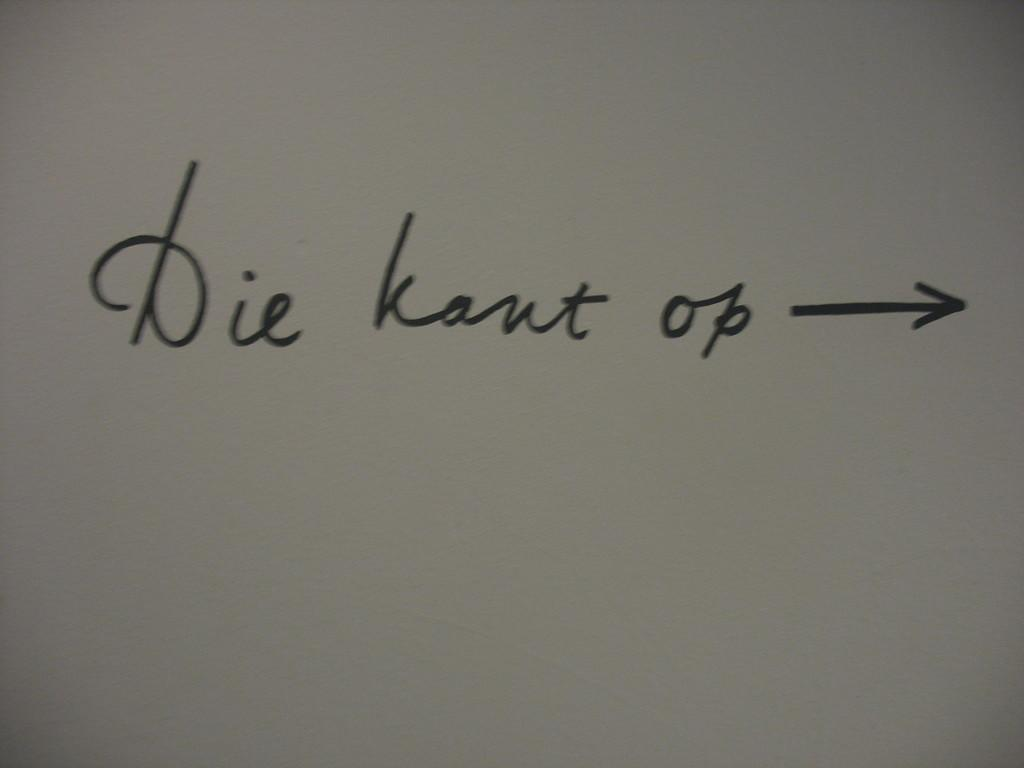<image>
Give a short and clear explanation of the subsequent image. Wrote in cursing is die kant op with a arrow pointing right 